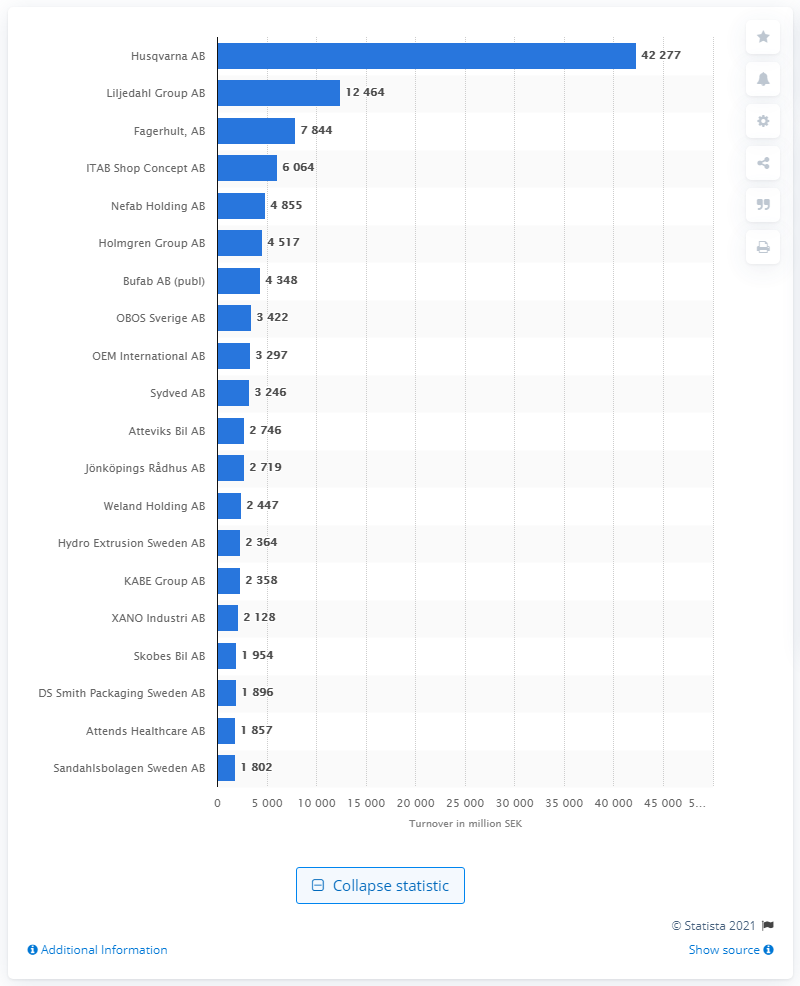Mention a couple of crucial points in this snapshot. The Liljedahl Group AB was the second most profitable company in Jnkping county in 2021, according to the records. The turnover of Liljedahl Group AB in 2021 was SEK 124,644. 